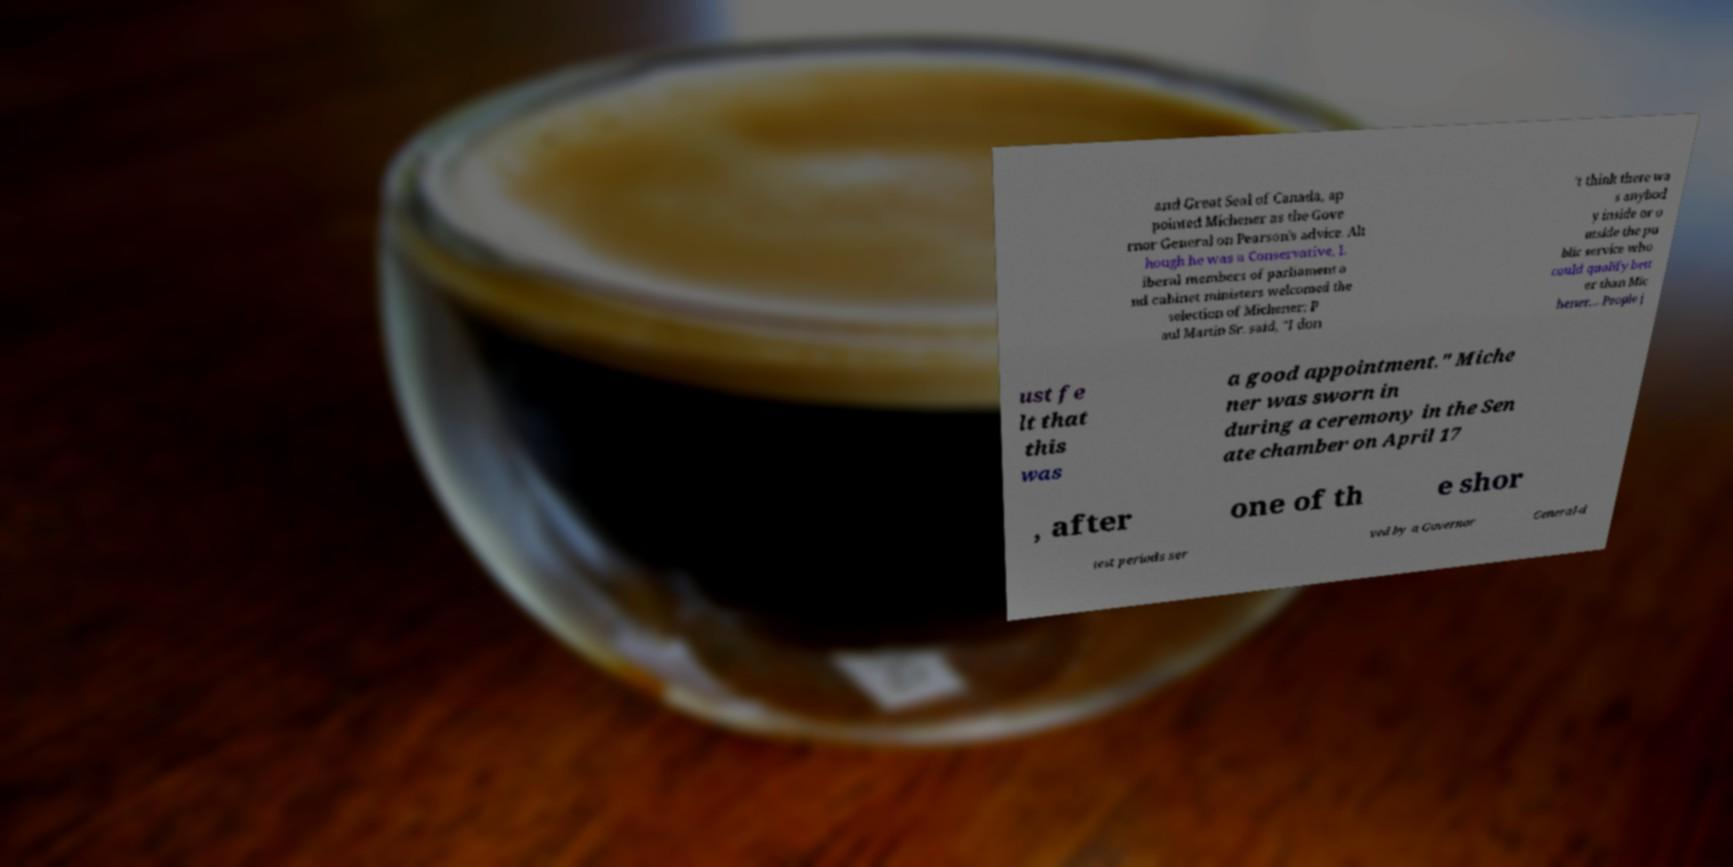Can you accurately transcribe the text from the provided image for me? and Great Seal of Canada, ap pointed Michener as the Gove rnor General on Pearson's advice. Alt hough he was a Conservative, L iberal members of parliament a nd cabinet ministers welcomed the selection of Michener; P aul Martin Sr. said, "I don ’t think there wa s anybod y inside or o utside the pu blic service who could qualify bett er than Mic hener... People j ust fe lt that this was a good appointment." Miche ner was sworn in during a ceremony in the Sen ate chamber on April 17 , after one of th e shor test periods ser ved by a Governor General-d 